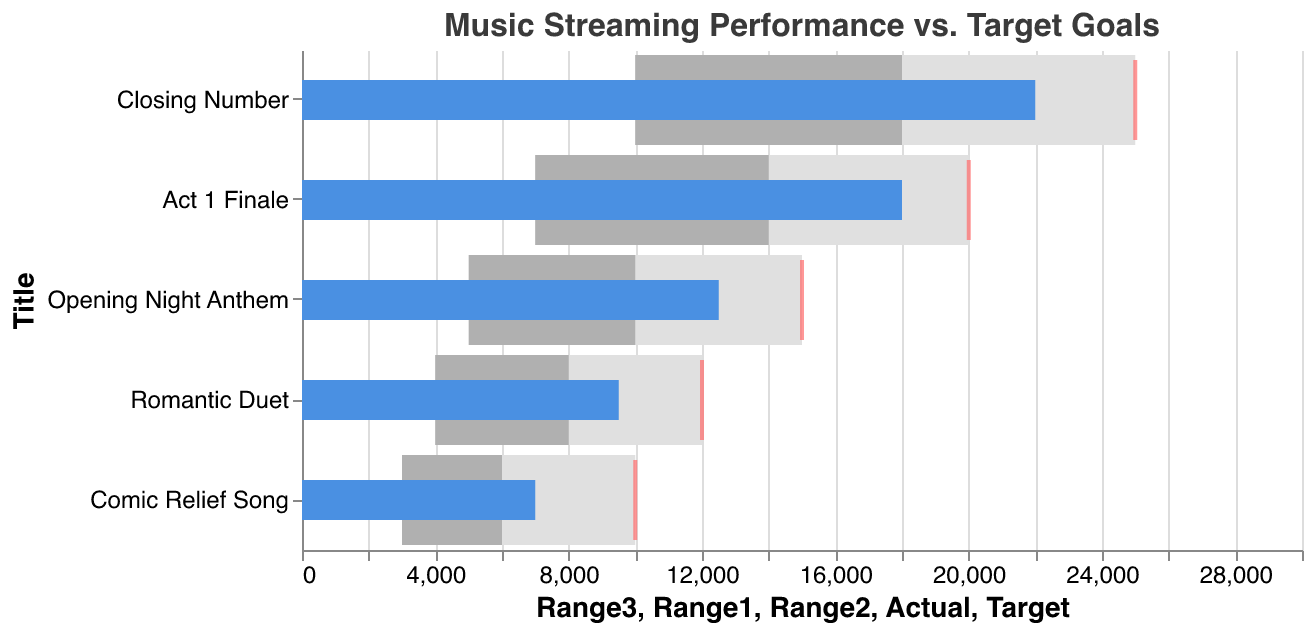What is the title of the figure? The title can be found at the top of the chart, which helps describe the overall subject of the figure.
Answer: Music Streaming Performance vs. Target Goals Which song had the highest number of actual streams? By examining the blue bars representing the Actual values, the song with the longest bar will have the highest number of streams. In this case, the "Closing Number" song has the longest bar.
Answer: Closing Number How much below the target is "Romantic Duet"? Subtract the Actual value from the Target value for "Romantic Duet". The target is 12000, and the actual performance is 9500. The difference is 12000 - 9500 = 2500.
Answer: 2500 What is the color used to denote the Target goals in this chart? The color for the Target goals can be identified by looking at the small ticks on the chart. They are marked in a distinguishable color, which is red in this chart.
Answer: Red If we rank the songs by performance (actual streams) from highest to lowest, what is the third song in the ranking? First, identify and list the Actual values for all songs, then sort them in descending order. The values are: Closing Number (22000), Act 1 Finale (18000), Opening Night Anthem (12500), Romantic Duet (9500), Comic Relief Song (7000). The third highest is "Opening Night Anthem".
Answer: Opening Night Anthem Which song met its top performance target (Range3)? A song meets its top performance target (Range3) if its Actual value equals or exceeds the Range3 value. By comparing Actual and Range3 values, none of the songs meet or exceed their Range3 targets.
Answer: None Which song has the closest actual performance to its target goal? Calculate the absolute difference between Actual and Target values for each song. The song with the smallest difference will be the closest. The differences are: Opening Night Anthem (2500), Act 1 Finale (2000), Romantic Duet (2500), Comic Relief Song (3000), Closing Number (3000). Therefore, "Act 1 Finale" and "Romantic Duet" are close, but "Act 1 Finale" is closer.
Answer: Act 1 Finale What proportion of the target was achieved by "Comic Relief Song"? The proportion achieved is given by Actual divided by Target. For "Comic Relief Song", the Actual is 7000 and the Target is 10000. So, the proportion is 7000 / 10000 = 0.7 (or 70%).
Answer: 70% How many songs fell short of their mid-range target (Range2)? Identify the songs whose Actual performance is below their Range2 target. The Actual values compared to Range2 are: Opening Night Anthem (12500 < 10000 — met), Act 1 Finale (18000 > 14000 — met), Romantic Duet (9500 < 8000 — met), Comic Relief Song (7000 < 6000 — not met), Closing Number (22000 > 18000 — met). Only "Comic Relief Song" fell short of its mid-range target.
Answer: 1 What is the total sum of Actual streams for all songs combined? Add up the Actual values for all the songs: 12500 (Opening Night Anthem) + 18000 (Act 1 Finale) + 9500 (Romantic Duet) + 7000 (Comic Relief Song) + 22000 (Closing Number) = 69000.
Answer: 69000 